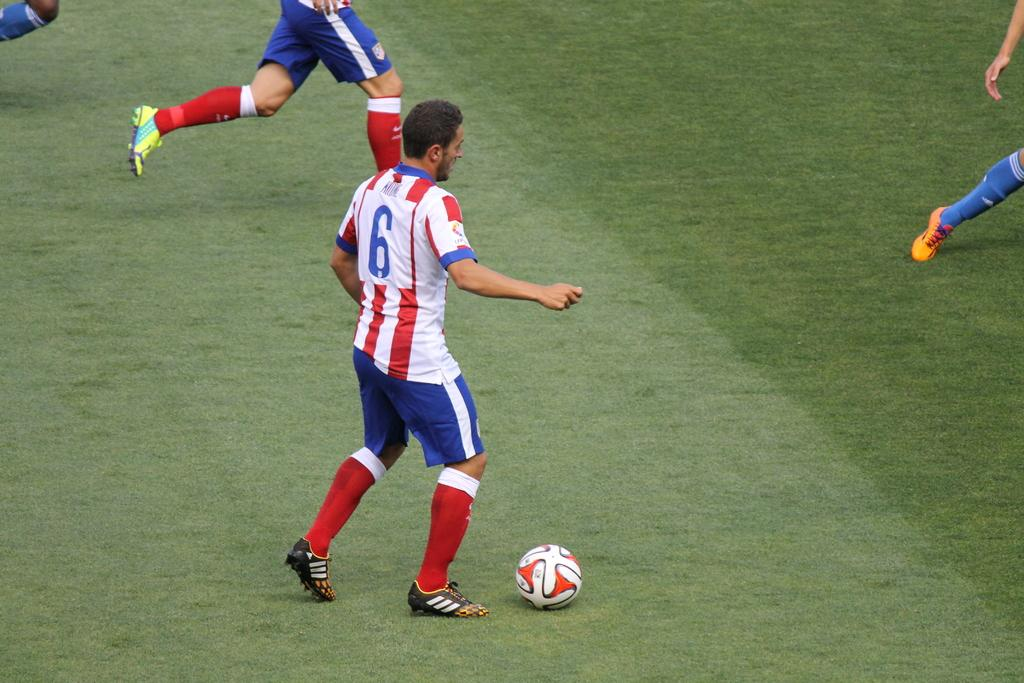<image>
Relay a brief, clear account of the picture shown. Soccer player wearing the number 6 about to kick a ball. 